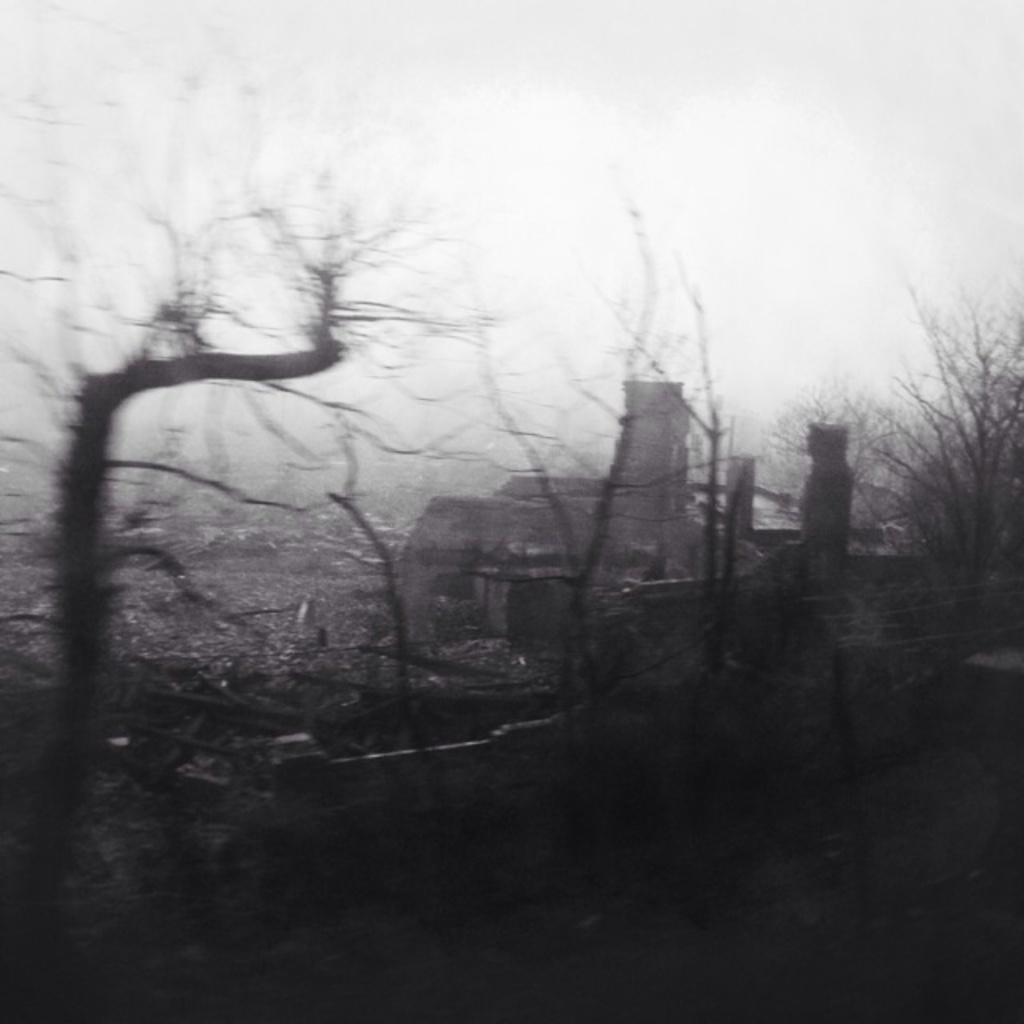What type of natural elements can be seen in the image? There are trees in the image. What type of man-made structure is present in the image? There is a building in the image. What part of the natural environment is visible in the image? The sky is visible in the image. What is the color scheme of the image? The image is black and white in color. What is the title of the book that the men are reading in the image? There are no men or books present in the image; it features trees, a building, and a black and white color scheme. 